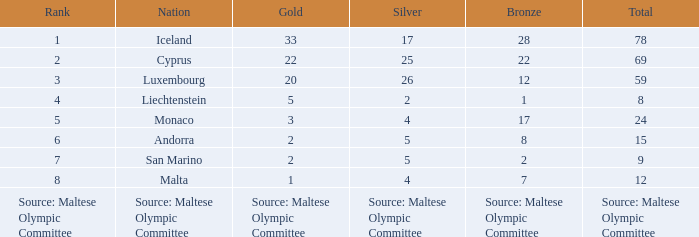Can you give me this table as a dict? {'header': ['Rank', 'Nation', 'Gold', 'Silver', 'Bronze', 'Total'], 'rows': [['1', 'Iceland', '33', '17', '28', '78'], ['2', 'Cyprus', '22', '25', '22', '69'], ['3', 'Luxembourg', '20', '26', '12', '59'], ['4', 'Liechtenstein', '5', '2', '1', '8'], ['5', 'Monaco', '3', '4', '17', '24'], ['6', 'Andorra', '2', '5', '8', '15'], ['7', 'San Marino', '2', '5', '2', '9'], ['8', 'Malta', '1', '4', '7', '12'], ['Source: Maltese Olympic Committee', 'Source: Maltese Olympic Committee', 'Source: Maltese Olympic Committee', 'Source: Maltese Olympic Committee', 'Source: Maltese Olympic Committee', 'Source: Maltese Olympic Committee']]} How many bronze medals does the nation ranked number 1 have? 28.0. 